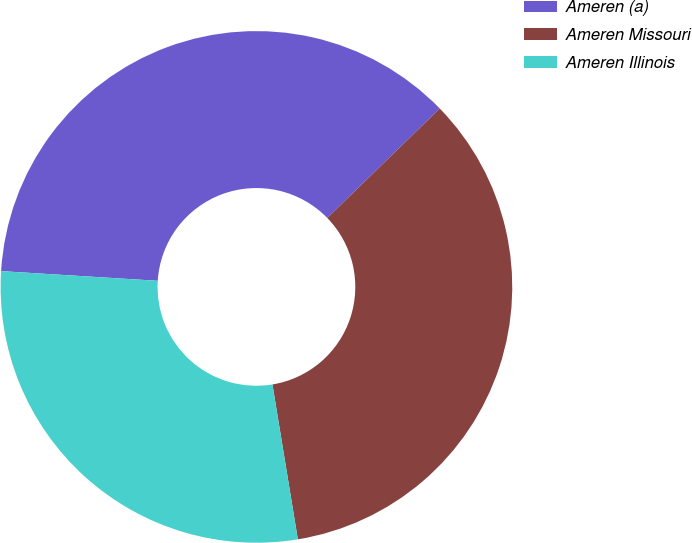<chart> <loc_0><loc_0><loc_500><loc_500><pie_chart><fcel>Ameren (a)<fcel>Ameren Missouri<fcel>Ameren Illinois<nl><fcel>36.73%<fcel>34.69%<fcel>28.57%<nl></chart> 